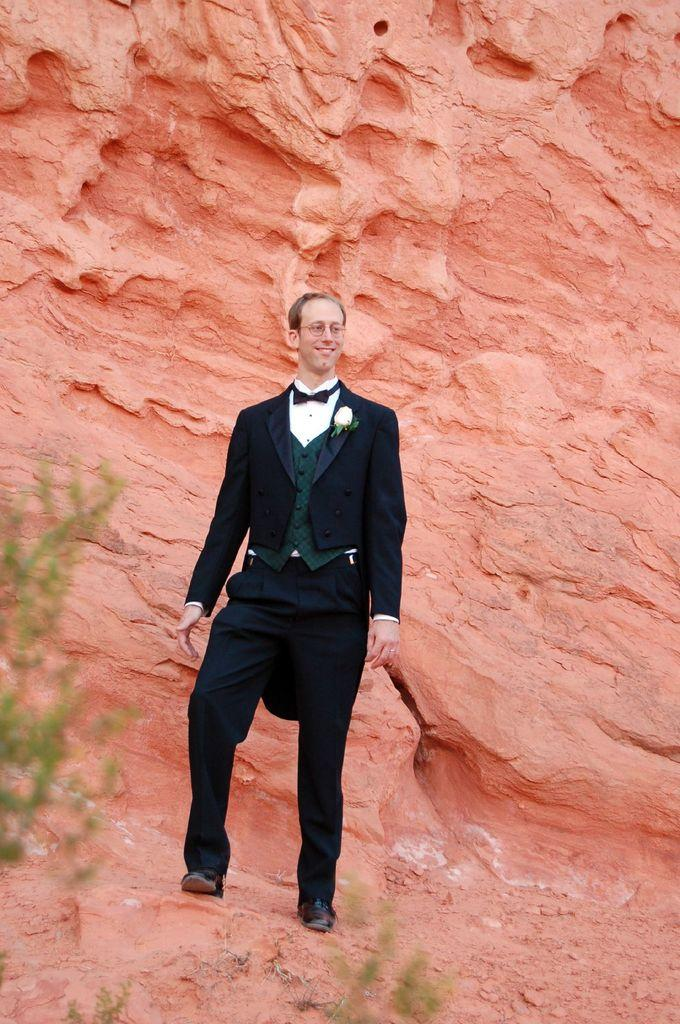Who or what is present in the image? There is a person in the image. What can be seen beneath the person's feet? The ground is visible in the image. What type of vegetation is present in the image? There are leaves on the left side and at the bottom of the image. What type of structure can be seen in the background? There is a stone wall in the background of the image. What type of crown is the person wearing in the image? There is no crown present in the image. How much does the poison weigh in the image? There is no poison present in the image. 